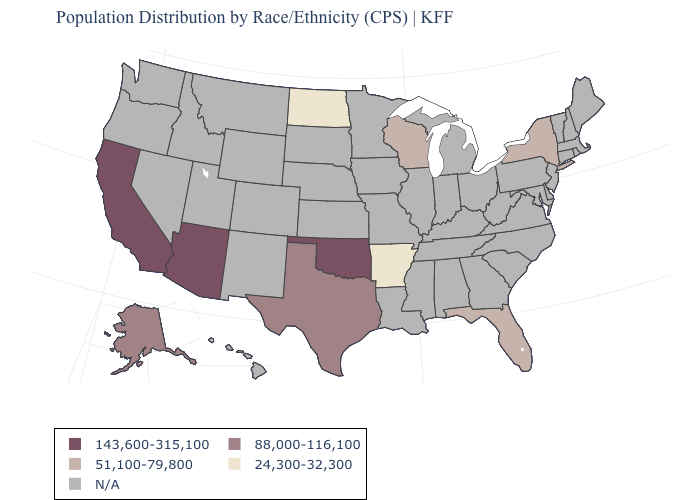Name the states that have a value in the range N/A?
Give a very brief answer. Alabama, Colorado, Connecticut, Delaware, Georgia, Hawaii, Idaho, Illinois, Indiana, Iowa, Kansas, Kentucky, Louisiana, Maine, Maryland, Massachusetts, Michigan, Minnesota, Mississippi, Missouri, Montana, Nebraska, Nevada, New Hampshire, New Jersey, New Mexico, North Carolina, Ohio, Oregon, Pennsylvania, Rhode Island, South Carolina, South Dakota, Tennessee, Utah, Vermont, Virginia, Washington, West Virginia, Wyoming. Which states have the highest value in the USA?
Keep it brief. Arizona, California, Oklahoma. What is the value of Rhode Island?
Short answer required. N/A. What is the value of Georgia?
Give a very brief answer. N/A. Name the states that have a value in the range 51,100-79,800?
Give a very brief answer. Florida, New York, Wisconsin. Which states have the highest value in the USA?
Write a very short answer. Arizona, California, Oklahoma. What is the value of Georgia?
Quick response, please. N/A. What is the lowest value in the USA?
Short answer required. 24,300-32,300. What is the value of Maine?
Short answer required. N/A. Name the states that have a value in the range N/A?
Short answer required. Alabama, Colorado, Connecticut, Delaware, Georgia, Hawaii, Idaho, Illinois, Indiana, Iowa, Kansas, Kentucky, Louisiana, Maine, Maryland, Massachusetts, Michigan, Minnesota, Mississippi, Missouri, Montana, Nebraska, Nevada, New Hampshire, New Jersey, New Mexico, North Carolina, Ohio, Oregon, Pennsylvania, Rhode Island, South Carolina, South Dakota, Tennessee, Utah, Vermont, Virginia, Washington, West Virginia, Wyoming. 